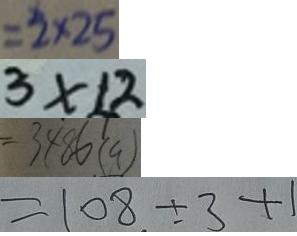<formula> <loc_0><loc_0><loc_500><loc_500>= 2 \times 2 5 
 3 \times 1 2 
 = 3 4 8 6 ( a ) 
 = 1 0 8 \div 3 + 1</formula> 